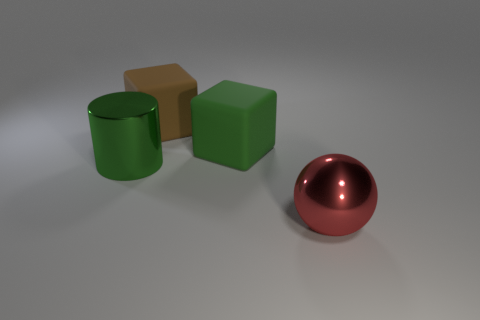What number of objects are large objects that are on the left side of the red shiny sphere or rubber blocks right of the brown matte cube?
Your answer should be compact. 3. The sphere has what color?
Offer a terse response. Red. Are there fewer big shiny balls that are behind the large sphere than yellow shiny balls?
Give a very brief answer. No. Is there any other thing that is the same shape as the red thing?
Provide a succinct answer. No. Are any red rubber balls visible?
Offer a very short reply. No. Is the number of big metal cylinders less than the number of big things?
Provide a succinct answer. Yes. What number of large green objects are the same material as the big green cylinder?
Ensure brevity in your answer.  0. There is a object that is made of the same material as the green cylinder; what color is it?
Keep it short and to the point. Red. What is the shape of the brown object?
Provide a short and direct response. Cube. How many cubes have the same color as the large metallic cylinder?
Your response must be concise. 1. 